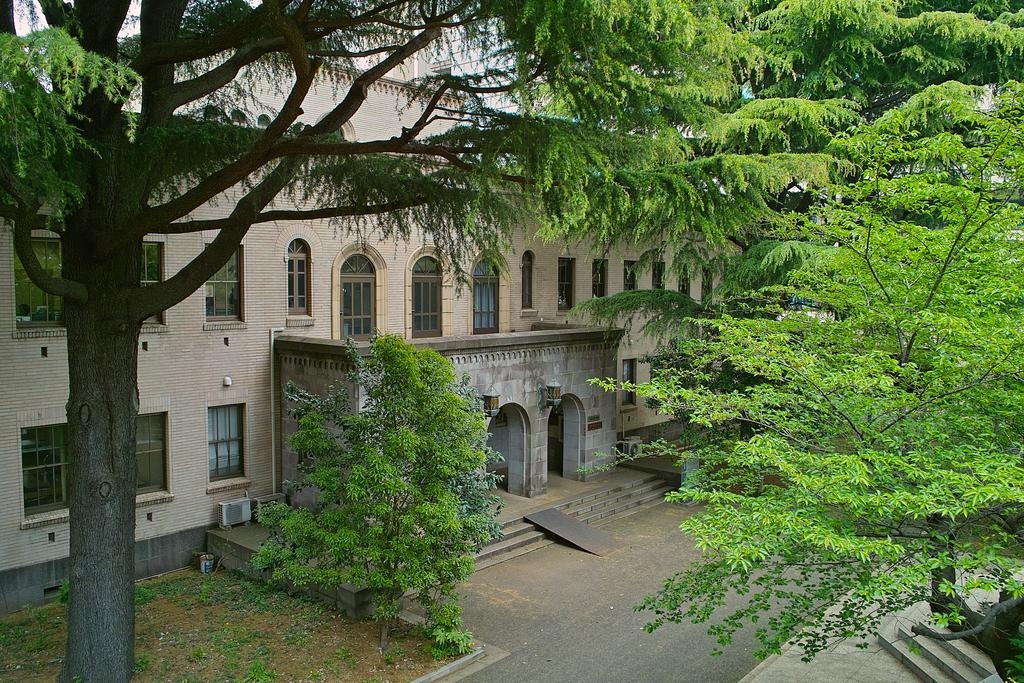What type of natural elements can be seen in the image? There are many trees in the image. What type of man-made structure is present in the image? There is a building in the image. What are the main features of the building? The building has walls, windows, pillars, and arches. What architectural feature is present at the entrance of the building? There are steps in front of the building. Can you see anyone smiling in the bedroom in the image? There is no bedroom present in the image, and therefore no one can be seen smiling in it. 